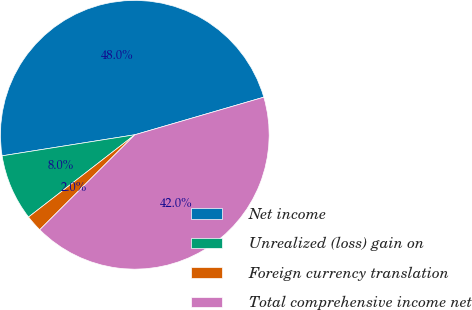Convert chart to OTSL. <chart><loc_0><loc_0><loc_500><loc_500><pie_chart><fcel>Net income<fcel>Unrealized (loss) gain on<fcel>Foreign currency translation<fcel>Total comprehensive income net<nl><fcel>47.99%<fcel>7.98%<fcel>2.01%<fcel>42.02%<nl></chart> 